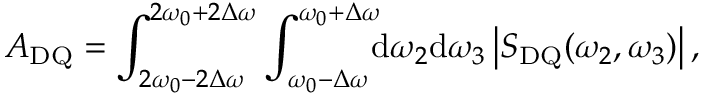Convert formula to latex. <formula><loc_0><loc_0><loc_500><loc_500>A _ { D Q } = \int _ { 2 \omega _ { 0 } - 2 \Delta \omega } ^ { 2 \omega _ { 0 } + 2 \Delta \omega } \int _ { \omega _ { 0 } - \Delta \omega } ^ { \omega _ { 0 } + \Delta \omega } \, { d } \omega _ { 2 } { d } \omega _ { 3 } \left | S _ { D Q } ( \omega _ { 2 } , \omega _ { 3 } ) \right | ,</formula> 